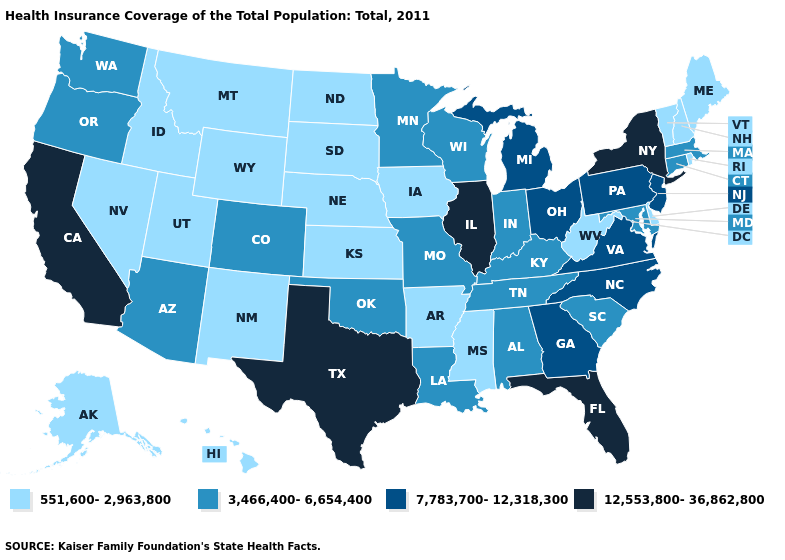What is the value of Louisiana?
Be succinct. 3,466,400-6,654,400. Name the states that have a value in the range 551,600-2,963,800?
Concise answer only. Alaska, Arkansas, Delaware, Hawaii, Idaho, Iowa, Kansas, Maine, Mississippi, Montana, Nebraska, Nevada, New Hampshire, New Mexico, North Dakota, Rhode Island, South Dakota, Utah, Vermont, West Virginia, Wyoming. Does New Mexico have the lowest value in the West?
Quick response, please. Yes. Is the legend a continuous bar?
Give a very brief answer. No. Among the states that border Maryland , does Delaware have the lowest value?
Quick response, please. Yes. What is the value of Louisiana?
Short answer required. 3,466,400-6,654,400. Among the states that border Vermont , does New Hampshire have the lowest value?
Write a very short answer. Yes. Name the states that have a value in the range 551,600-2,963,800?
Concise answer only. Alaska, Arkansas, Delaware, Hawaii, Idaho, Iowa, Kansas, Maine, Mississippi, Montana, Nebraska, Nevada, New Hampshire, New Mexico, North Dakota, Rhode Island, South Dakota, Utah, Vermont, West Virginia, Wyoming. Name the states that have a value in the range 7,783,700-12,318,300?
Quick response, please. Georgia, Michigan, New Jersey, North Carolina, Ohio, Pennsylvania, Virginia. Among the states that border New Jersey , does Pennsylvania have the highest value?
Give a very brief answer. No. What is the lowest value in states that border North Carolina?
Concise answer only. 3,466,400-6,654,400. Does the map have missing data?
Quick response, please. No. What is the value of Minnesota?
Quick response, please. 3,466,400-6,654,400. What is the lowest value in the USA?
Short answer required. 551,600-2,963,800. What is the lowest value in states that border Indiana?
Give a very brief answer. 3,466,400-6,654,400. 